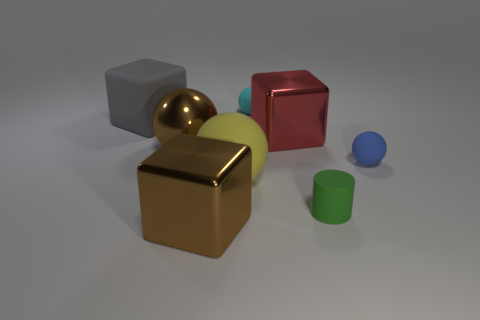How many big gray rubber cubes are there?
Ensure brevity in your answer.  1. What number of metal objects are to the right of the green rubber thing?
Your response must be concise. 0. Does the gray thing have the same material as the yellow sphere?
Ensure brevity in your answer.  Yes. How many matte things are both to the left of the large brown cube and behind the big matte block?
Ensure brevity in your answer.  0. How many other objects are there of the same color as the cylinder?
Make the answer very short. 0. What number of brown things are big rubber blocks or matte cylinders?
Keep it short and to the point. 0. The blue sphere is what size?
Make the answer very short. Small. What number of metallic things are tiny red objects or large objects?
Make the answer very short. 3. Is the number of cyan rubber spheres less than the number of tiny gray things?
Make the answer very short. No. What number of other objects are the same material as the big brown ball?
Provide a succinct answer. 2. 